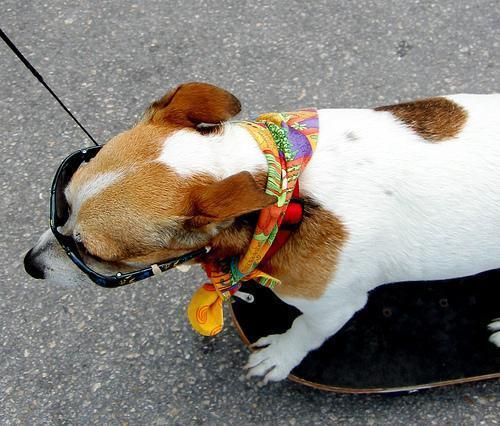How many dogs are in the picture?
Give a very brief answer. 1. 